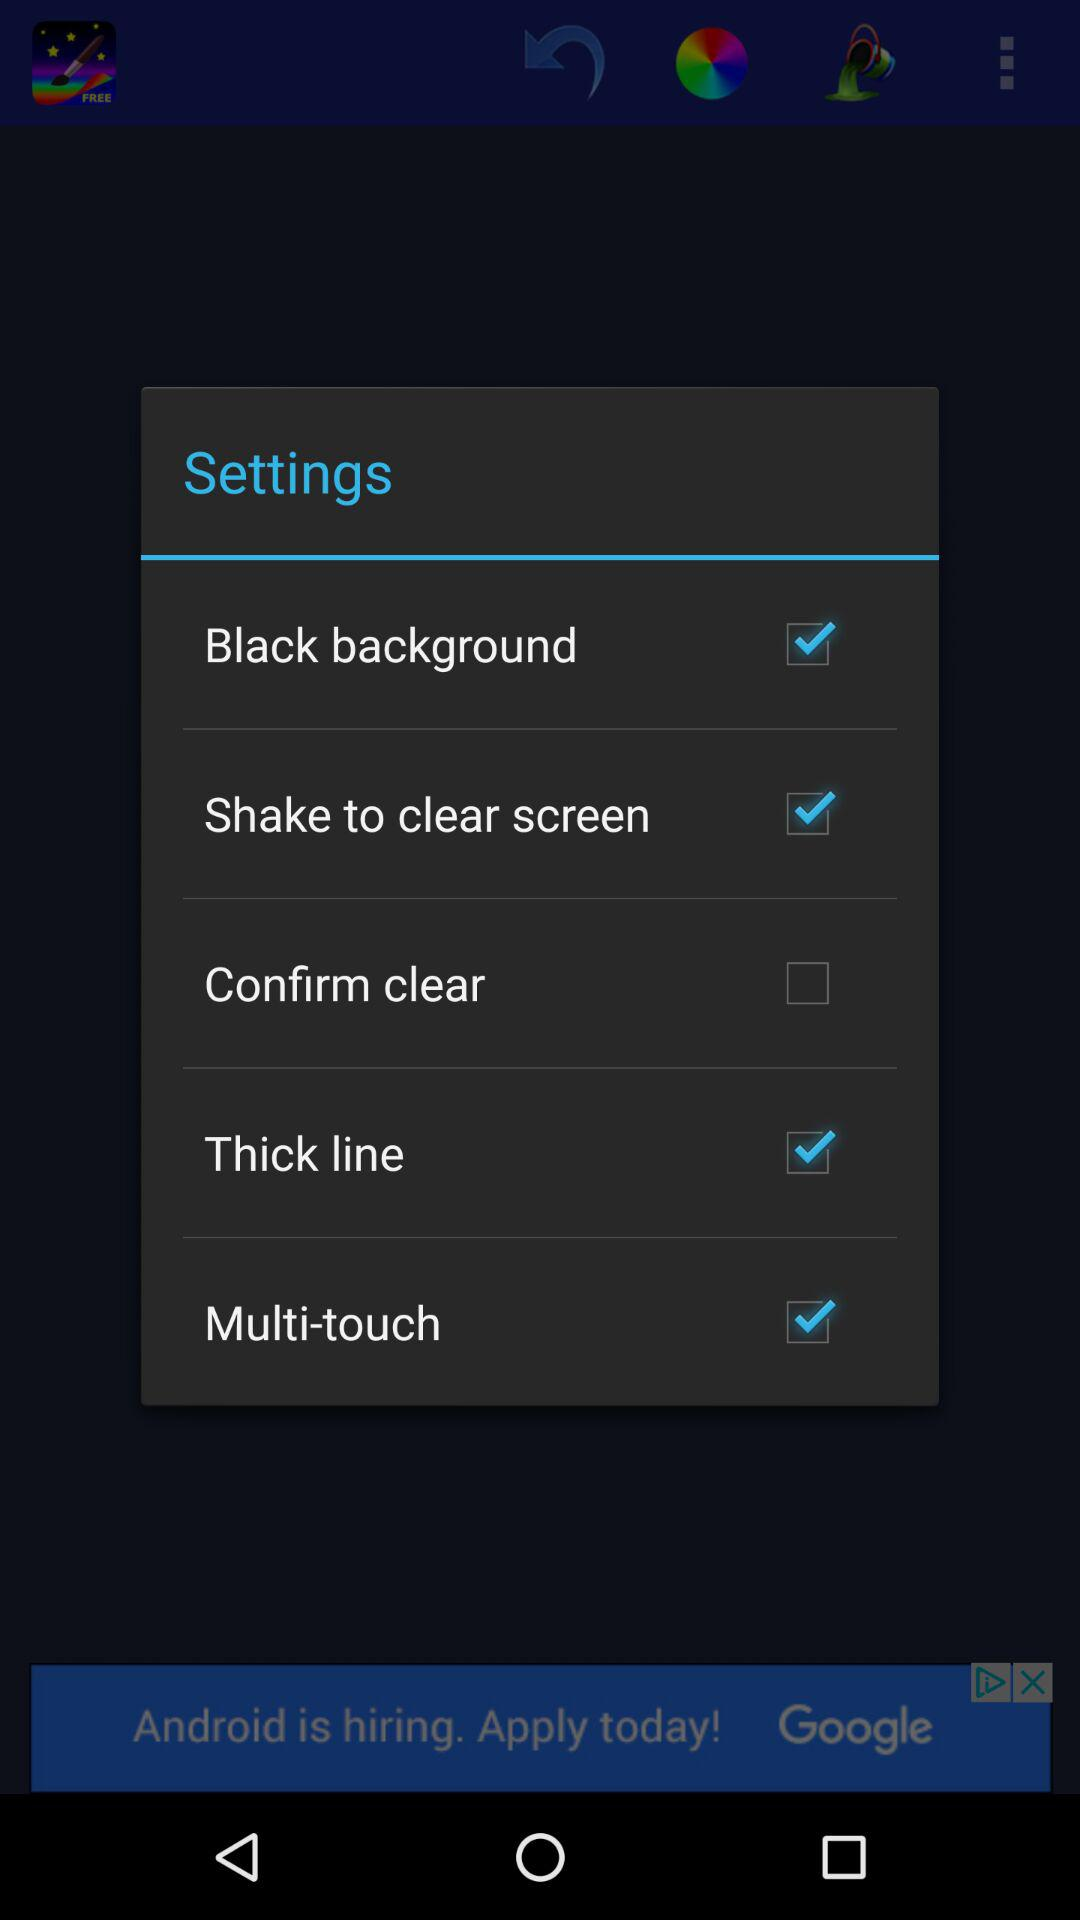Which setting is unchecked? The unchecked setting is "Confirm clear". 